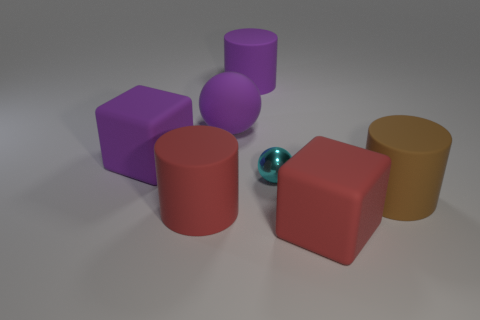Are there any other things that have the same size as the metal object?
Your response must be concise. No. The cylinder that is the same color as the rubber sphere is what size?
Offer a very short reply. Large. What number of tiny objects are either brown rubber cylinders or yellow spheres?
Give a very brief answer. 0. There is another big thing that is the same shape as the shiny thing; what is its color?
Provide a succinct answer. Purple. Do the purple matte cube and the red cylinder have the same size?
Keep it short and to the point. Yes. What number of things are large purple things or blocks that are on the right side of the tiny metal thing?
Ensure brevity in your answer.  4. There is a rubber cylinder that is to the right of the thing in front of the red rubber cylinder; what color is it?
Offer a terse response. Brown. Is the color of the matte block in front of the cyan object the same as the small thing?
Offer a very short reply. No. What is the material of the large block left of the red block?
Your answer should be very brief. Rubber. The purple cylinder is what size?
Ensure brevity in your answer.  Large. 